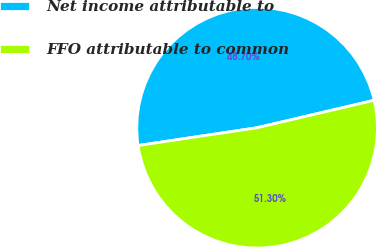<chart> <loc_0><loc_0><loc_500><loc_500><pie_chart><fcel>Net income attributable to<fcel>FFO attributable to common<nl><fcel>48.7%<fcel>51.3%<nl></chart> 